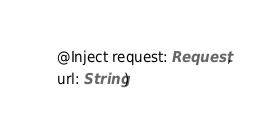Convert code to text. <code><loc_0><loc_0><loc_500><loc_500><_Scala_>  @Inject request: Request,
  url: String)
</code> 